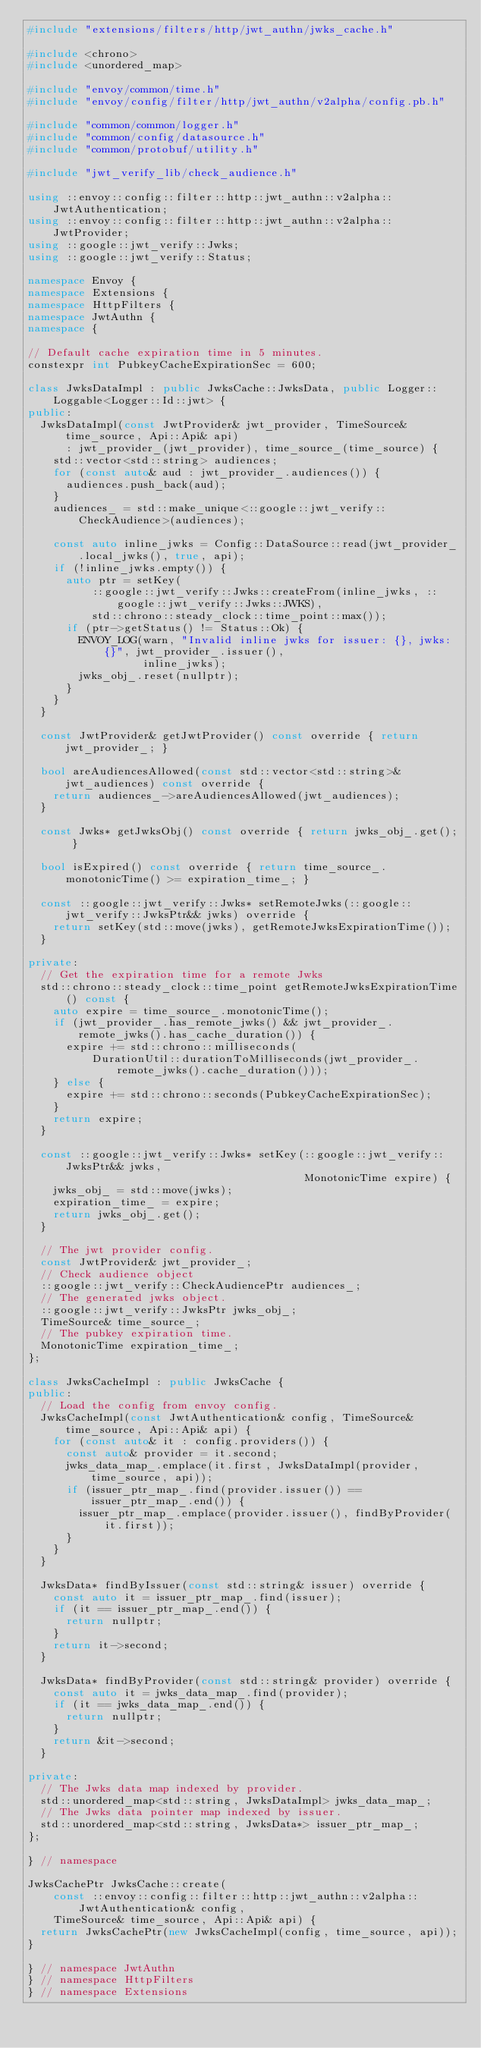<code> <loc_0><loc_0><loc_500><loc_500><_C++_>#include "extensions/filters/http/jwt_authn/jwks_cache.h"

#include <chrono>
#include <unordered_map>

#include "envoy/common/time.h"
#include "envoy/config/filter/http/jwt_authn/v2alpha/config.pb.h"

#include "common/common/logger.h"
#include "common/config/datasource.h"
#include "common/protobuf/utility.h"

#include "jwt_verify_lib/check_audience.h"

using ::envoy::config::filter::http::jwt_authn::v2alpha::JwtAuthentication;
using ::envoy::config::filter::http::jwt_authn::v2alpha::JwtProvider;
using ::google::jwt_verify::Jwks;
using ::google::jwt_verify::Status;

namespace Envoy {
namespace Extensions {
namespace HttpFilters {
namespace JwtAuthn {
namespace {

// Default cache expiration time in 5 minutes.
constexpr int PubkeyCacheExpirationSec = 600;

class JwksDataImpl : public JwksCache::JwksData, public Logger::Loggable<Logger::Id::jwt> {
public:
  JwksDataImpl(const JwtProvider& jwt_provider, TimeSource& time_source, Api::Api& api)
      : jwt_provider_(jwt_provider), time_source_(time_source) {
    std::vector<std::string> audiences;
    for (const auto& aud : jwt_provider_.audiences()) {
      audiences.push_back(aud);
    }
    audiences_ = std::make_unique<::google::jwt_verify::CheckAudience>(audiences);

    const auto inline_jwks = Config::DataSource::read(jwt_provider_.local_jwks(), true, api);
    if (!inline_jwks.empty()) {
      auto ptr = setKey(
          ::google::jwt_verify::Jwks::createFrom(inline_jwks, ::google::jwt_verify::Jwks::JWKS),
          std::chrono::steady_clock::time_point::max());
      if (ptr->getStatus() != Status::Ok) {
        ENVOY_LOG(warn, "Invalid inline jwks for issuer: {}, jwks: {}", jwt_provider_.issuer(),
                  inline_jwks);
        jwks_obj_.reset(nullptr);
      }
    }
  }

  const JwtProvider& getJwtProvider() const override { return jwt_provider_; }

  bool areAudiencesAllowed(const std::vector<std::string>& jwt_audiences) const override {
    return audiences_->areAudiencesAllowed(jwt_audiences);
  }

  const Jwks* getJwksObj() const override { return jwks_obj_.get(); }

  bool isExpired() const override { return time_source_.monotonicTime() >= expiration_time_; }

  const ::google::jwt_verify::Jwks* setRemoteJwks(::google::jwt_verify::JwksPtr&& jwks) override {
    return setKey(std::move(jwks), getRemoteJwksExpirationTime());
  }

private:
  // Get the expiration time for a remote Jwks
  std::chrono::steady_clock::time_point getRemoteJwksExpirationTime() const {
    auto expire = time_source_.monotonicTime();
    if (jwt_provider_.has_remote_jwks() && jwt_provider_.remote_jwks().has_cache_duration()) {
      expire += std::chrono::milliseconds(
          DurationUtil::durationToMilliseconds(jwt_provider_.remote_jwks().cache_duration()));
    } else {
      expire += std::chrono::seconds(PubkeyCacheExpirationSec);
    }
    return expire;
  }

  const ::google::jwt_verify::Jwks* setKey(::google::jwt_verify::JwksPtr&& jwks,
                                           MonotonicTime expire) {
    jwks_obj_ = std::move(jwks);
    expiration_time_ = expire;
    return jwks_obj_.get();
  }

  // The jwt provider config.
  const JwtProvider& jwt_provider_;
  // Check audience object
  ::google::jwt_verify::CheckAudiencePtr audiences_;
  // The generated jwks object.
  ::google::jwt_verify::JwksPtr jwks_obj_;
  TimeSource& time_source_;
  // The pubkey expiration time.
  MonotonicTime expiration_time_;
};

class JwksCacheImpl : public JwksCache {
public:
  // Load the config from envoy config.
  JwksCacheImpl(const JwtAuthentication& config, TimeSource& time_source, Api::Api& api) {
    for (const auto& it : config.providers()) {
      const auto& provider = it.second;
      jwks_data_map_.emplace(it.first, JwksDataImpl(provider, time_source, api));
      if (issuer_ptr_map_.find(provider.issuer()) == issuer_ptr_map_.end()) {
        issuer_ptr_map_.emplace(provider.issuer(), findByProvider(it.first));
      }
    }
  }

  JwksData* findByIssuer(const std::string& issuer) override {
    const auto it = issuer_ptr_map_.find(issuer);
    if (it == issuer_ptr_map_.end()) {
      return nullptr;
    }
    return it->second;
  }

  JwksData* findByProvider(const std::string& provider) override {
    const auto it = jwks_data_map_.find(provider);
    if (it == jwks_data_map_.end()) {
      return nullptr;
    }
    return &it->second;
  }

private:
  // The Jwks data map indexed by provider.
  std::unordered_map<std::string, JwksDataImpl> jwks_data_map_;
  // The Jwks data pointer map indexed by issuer.
  std::unordered_map<std::string, JwksData*> issuer_ptr_map_;
};

} // namespace

JwksCachePtr JwksCache::create(
    const ::envoy::config::filter::http::jwt_authn::v2alpha::JwtAuthentication& config,
    TimeSource& time_source, Api::Api& api) {
  return JwksCachePtr(new JwksCacheImpl(config, time_source, api));
}

} // namespace JwtAuthn
} // namespace HttpFilters
} // namespace Extensions</code> 